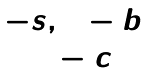<formula> <loc_0><loc_0><loc_500><loc_500>\begin{matrix} - s , 1 - b \\ 1 - c \end{matrix}</formula> 